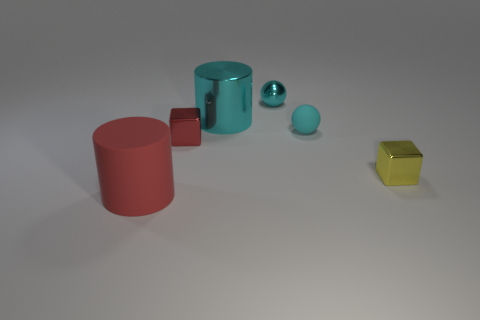What is the shape of the large shiny object?
Ensure brevity in your answer.  Cylinder. What size is the cyan shiny thing to the right of the big cylinder that is behind the red metallic cube?
Offer a very short reply. Small. How many things are tiny yellow blocks or small gray metallic spheres?
Your answer should be very brief. 1. Is the shape of the yellow shiny object the same as the large cyan metal object?
Offer a very short reply. No. Are there any yellow blocks that have the same material as the red block?
Ensure brevity in your answer.  Yes. There is a small cyan ball right of the tiny cyan metallic thing; is there a small yellow thing that is on the left side of it?
Provide a succinct answer. No. Do the matte thing to the left of the cyan matte ball and the red shiny thing have the same size?
Offer a terse response. No. The cyan rubber ball has what size?
Ensure brevity in your answer.  Small. Are there any small cubes of the same color as the shiny ball?
Provide a short and direct response. No. What number of big things are either cylinders or cyan matte things?
Your answer should be compact. 2. 